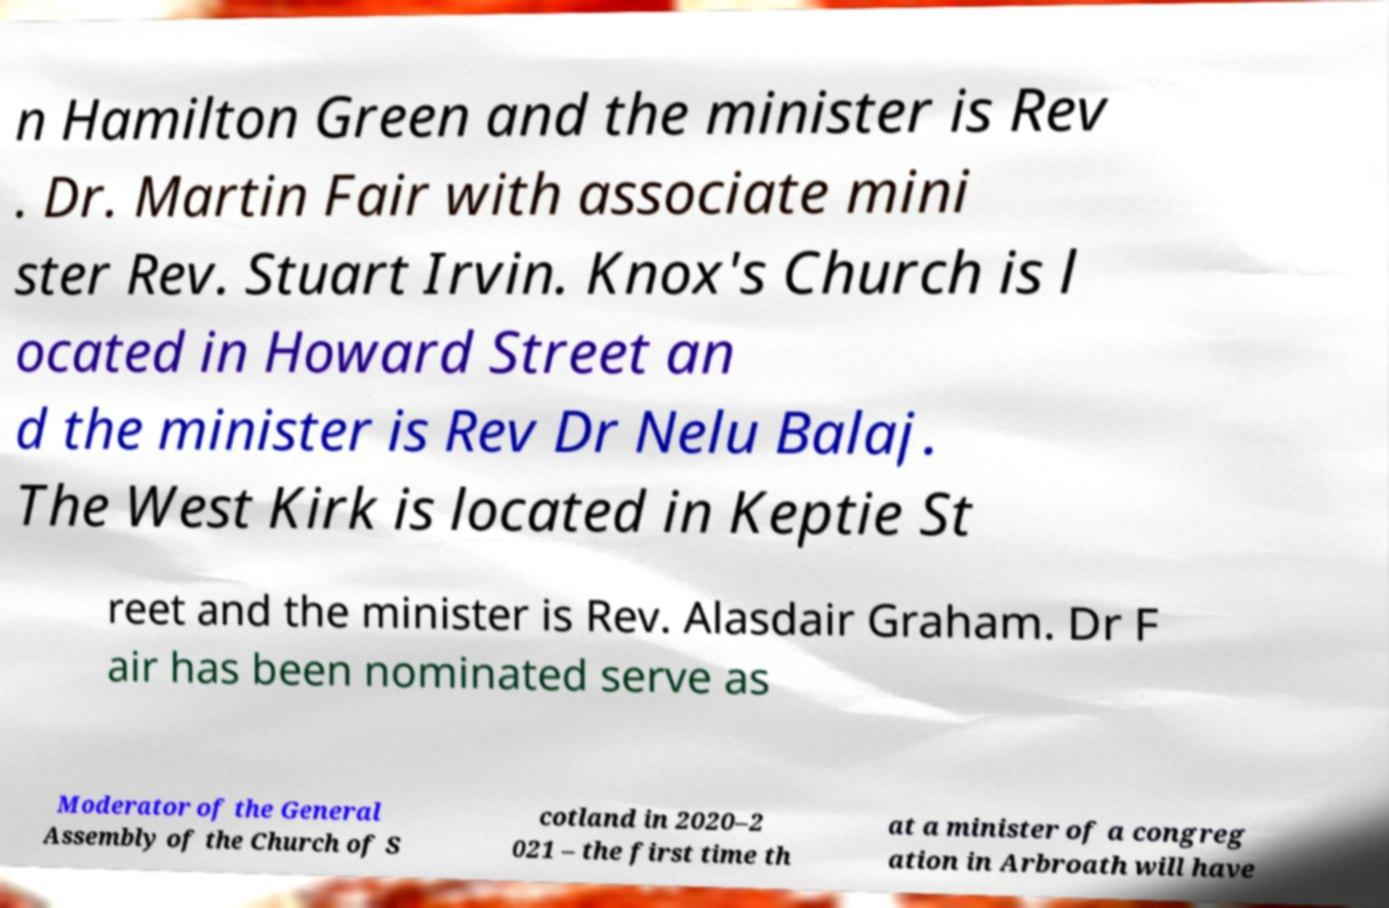For documentation purposes, I need the text within this image transcribed. Could you provide that? n Hamilton Green and the minister is Rev . Dr. Martin Fair with associate mini ster Rev. Stuart Irvin. Knox's Church is l ocated in Howard Street an d the minister is Rev Dr Nelu Balaj. The West Kirk is located in Keptie St reet and the minister is Rev. Alasdair Graham. Dr F air has been nominated serve as Moderator of the General Assembly of the Church of S cotland in 2020–2 021 – the first time th at a minister of a congreg ation in Arbroath will have 